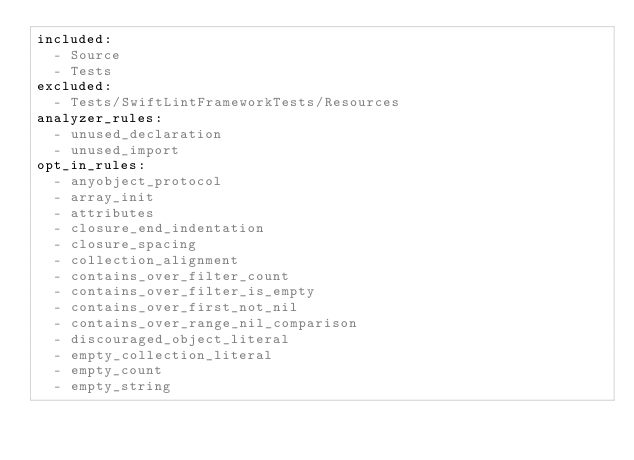<code> <loc_0><loc_0><loc_500><loc_500><_YAML_>included:
  - Source
  - Tests
excluded:
  - Tests/SwiftLintFrameworkTests/Resources
analyzer_rules:
  - unused_declaration
  - unused_import
opt_in_rules:
  - anyobject_protocol
  - array_init
  - attributes
  - closure_end_indentation
  - closure_spacing
  - collection_alignment
  - contains_over_filter_count
  - contains_over_filter_is_empty
  - contains_over_first_not_nil
  - contains_over_range_nil_comparison
  - discouraged_object_literal
  - empty_collection_literal
  - empty_count
  - empty_string</code> 